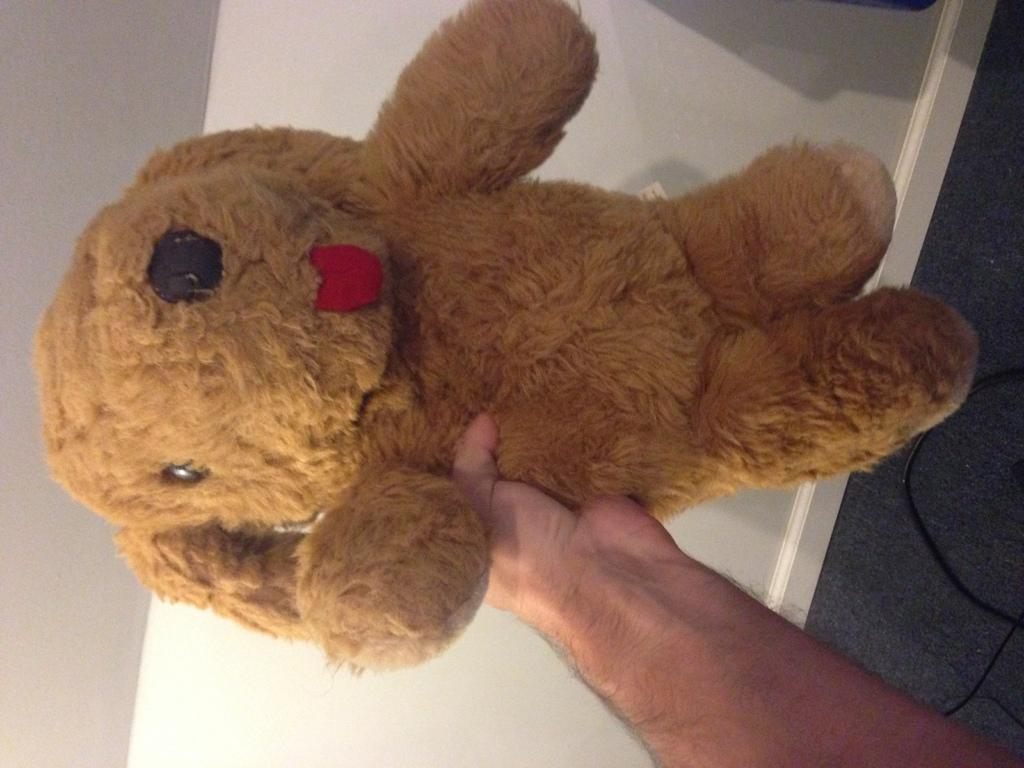What is being held by the person's hand in the image? The person's hand is holding a soft toy. Can you describe the soft toy? The soft toy is brown in color. What is visible in the background of the image? There is a white surface in the background of the image. What else can be seen in the image besides the person's hand and the soft toy? There are wires visible in the image. What type of bead is being used in the battle depicted in the image? There is no battle or bead present in the image; it features a person's hand holding a brown soft toy against a white background with visible wires. 